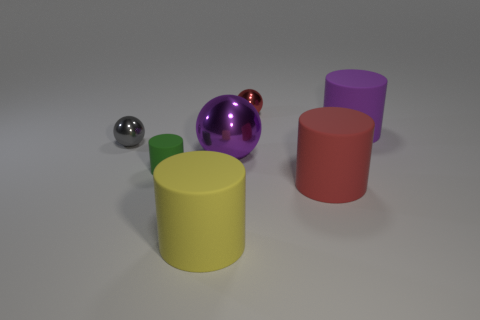Subtract all red metal spheres. How many spheres are left? 2 Subtract all purple spheres. How many spheres are left? 2 Subtract 0 green spheres. How many objects are left? 7 Subtract all cylinders. How many objects are left? 3 Subtract 2 spheres. How many spheres are left? 1 Subtract all gray cylinders. Subtract all blue cubes. How many cylinders are left? 4 Subtract all yellow blocks. How many cyan cylinders are left? 0 Subtract all small matte cylinders. Subtract all purple rubber cylinders. How many objects are left? 5 Add 1 large purple objects. How many large purple objects are left? 3 Add 5 big purple rubber objects. How many big purple rubber objects exist? 6 